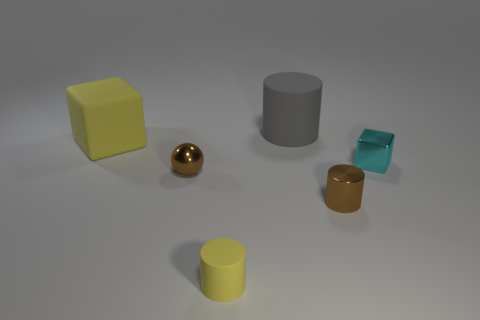Are the yellow object that is in front of the tiny metal block and the cylinder behind the tiny cyan cube made of the same material?
Offer a very short reply. Yes. How many other things are the same size as the gray cylinder?
Your answer should be very brief. 1. What number of objects are gray metallic cubes or objects in front of the yellow block?
Ensure brevity in your answer.  4. Is the number of small things that are right of the large yellow cube the same as the number of blocks?
Your response must be concise. No. The tiny brown object that is the same material as the small brown cylinder is what shape?
Offer a terse response. Sphere. Is there a small rubber object that has the same color as the metallic ball?
Give a very brief answer. No. How many rubber objects are big blocks or gray cylinders?
Make the answer very short. 2. What number of yellow matte things are right of the block left of the brown metal ball?
Your response must be concise. 1. How many big things have the same material as the small sphere?
Your answer should be very brief. 0. How many large objects are balls or cyan metallic blocks?
Offer a terse response. 0. 